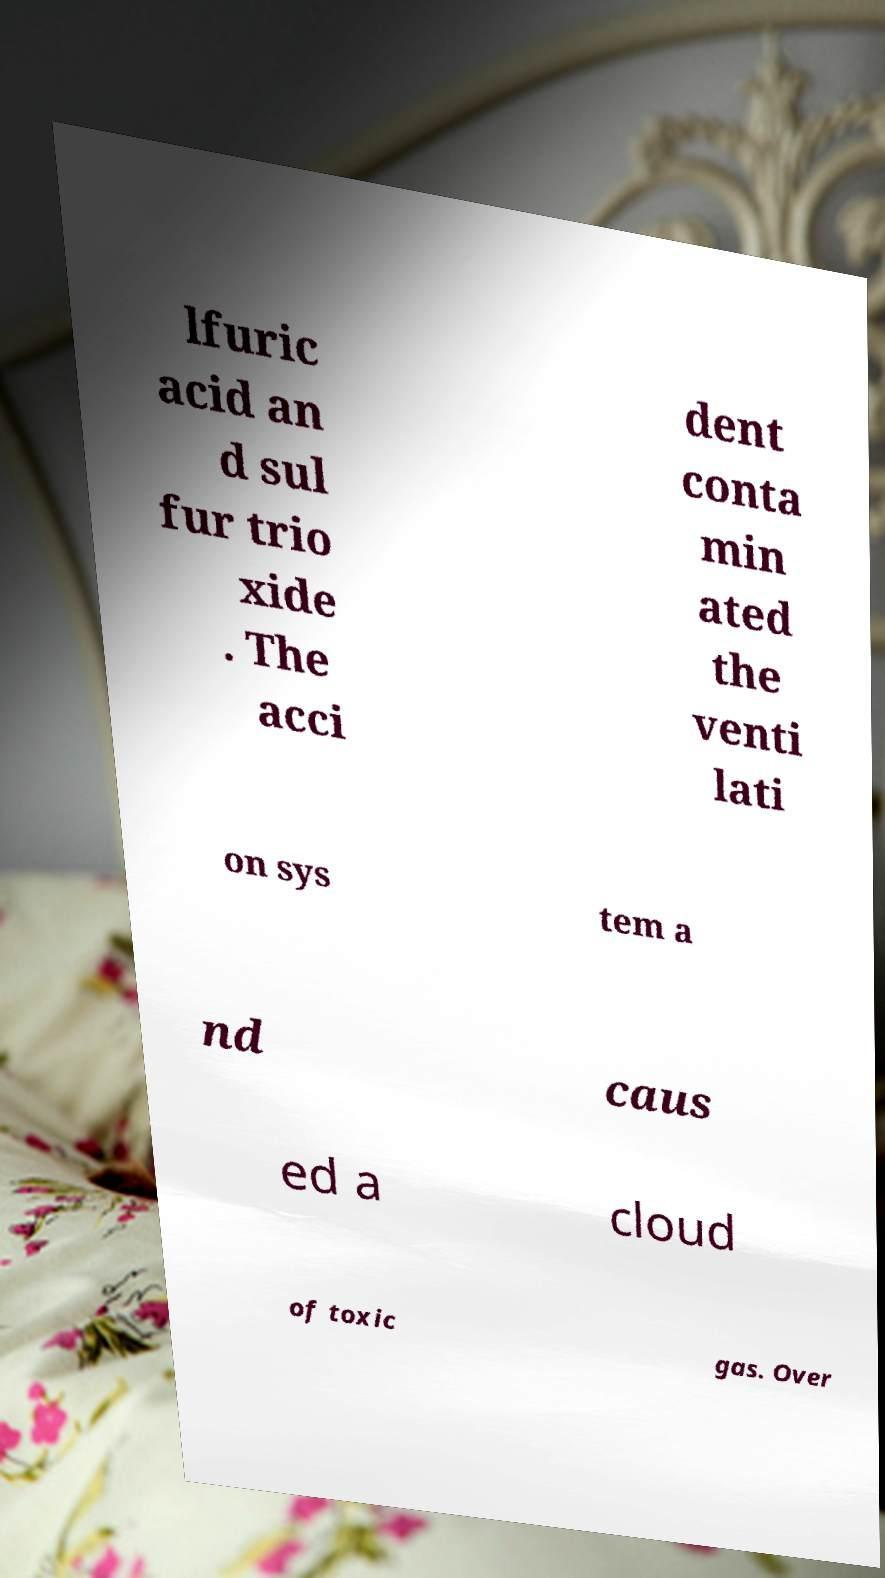What messages or text are displayed in this image? I need them in a readable, typed format. lfuric acid an d sul fur trio xide . The acci dent conta min ated the venti lati on sys tem a nd caus ed a cloud of toxic gas. Over 